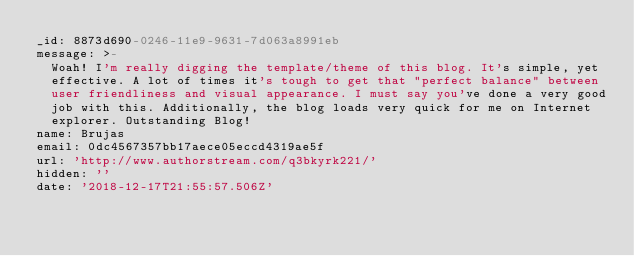Convert code to text. <code><loc_0><loc_0><loc_500><loc_500><_YAML_>_id: 8873d690-0246-11e9-9631-7d063a8991eb
message: >-
  Woah! I'm really digging the template/theme of this blog. It's simple, yet
  effective. A lot of times it's tough to get that "perfect balance" between
  user friendliness and visual appearance. I must say you've done a very good
  job with this. Additionally, the blog loads very quick for me on Internet
  explorer. Outstanding Blog!
name: Brujas
email: 0dc4567357bb17aece05eccd4319ae5f
url: 'http://www.authorstream.com/q3bkyrk221/'
hidden: ''
date: '2018-12-17T21:55:57.506Z'
</code> 